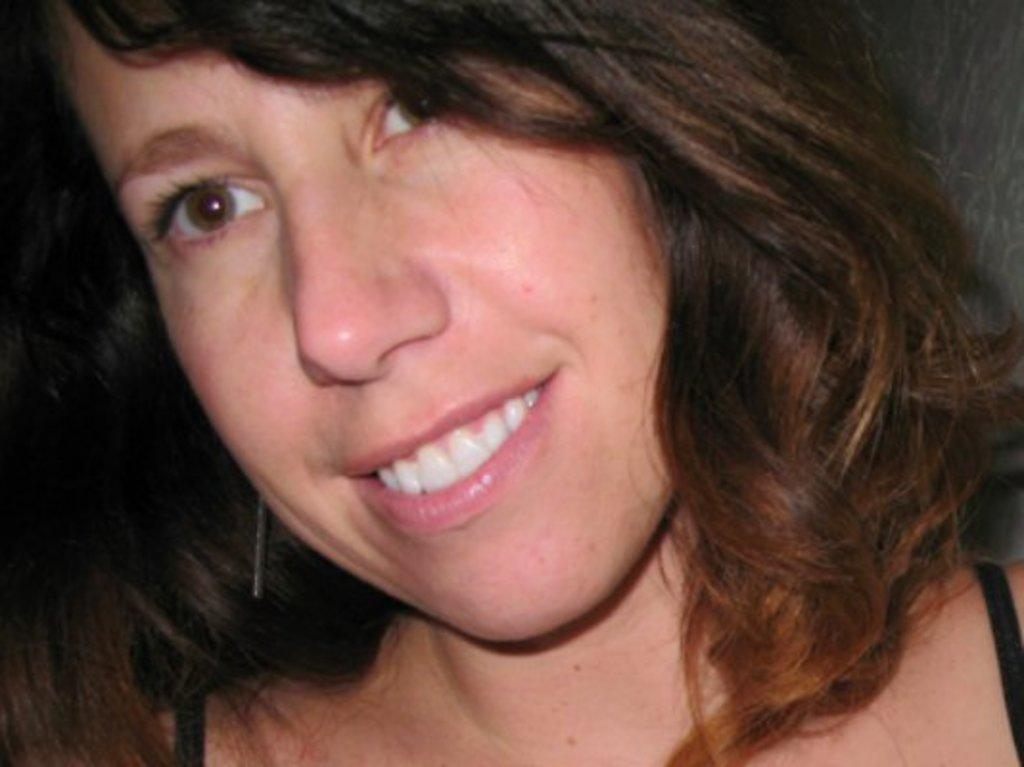What is the main subject of the image? There is a woman in the image. What is the woman's facial expression? The woman is smiling. What color is the dress the woman is wearing? The woman is wearing a black dress. What type of growth can be seen on the woman's face in the image? There is no growth visible on the woman's face in the image. What kind of stamp is the woman holding in the image? There is no stamp present in the image. 